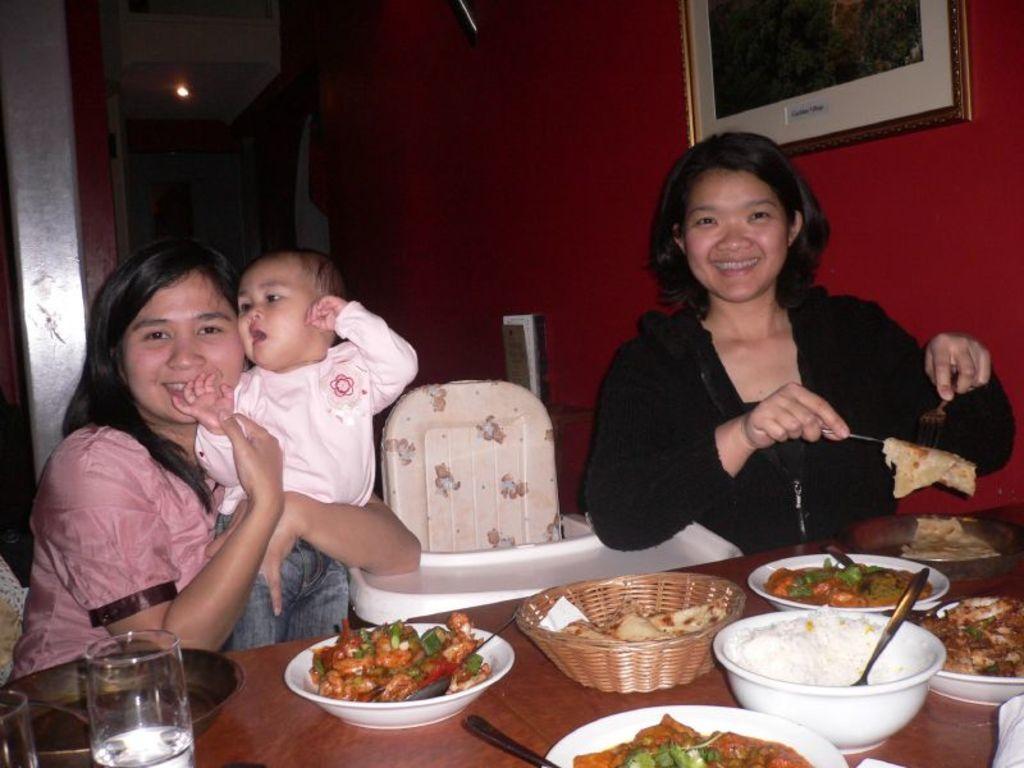Describe this image in one or two sentences. In this image two woman are sitting before a table having few bowls, plate, basket, glasses are on it. Bowls are having some food and spoon in it. Basket is having some food in it. A woman wearing a black jacket is holding some food with spoon and fork. A woman is holding a baby in her arms. A picture frame is attached to the wall. A light is attached to the roof. 